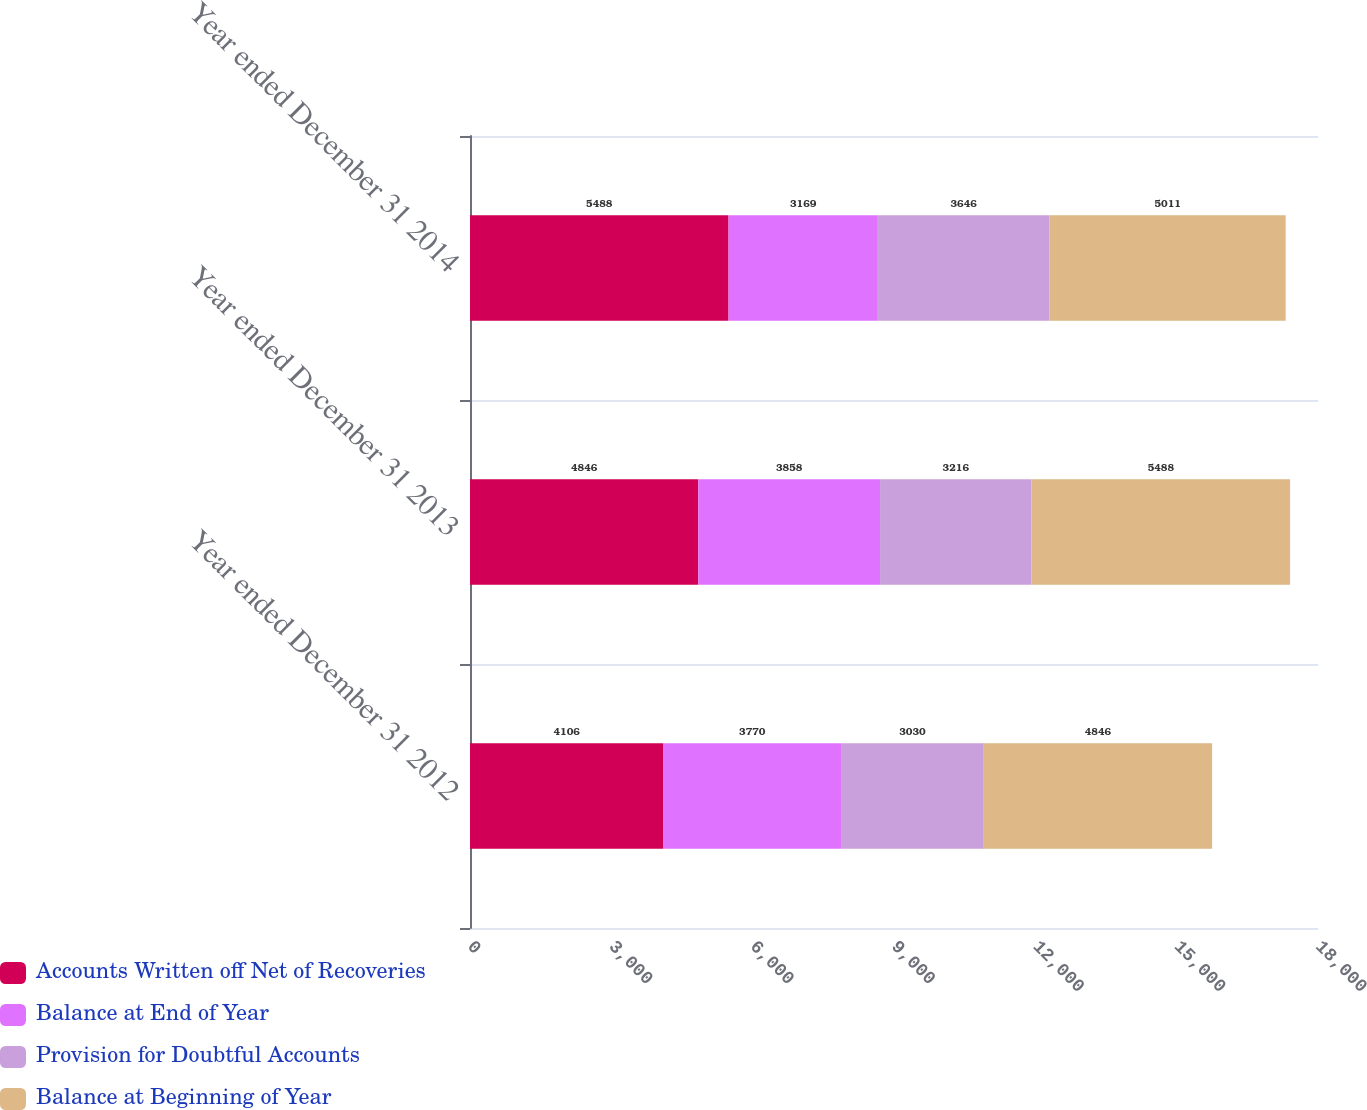Convert chart to OTSL. <chart><loc_0><loc_0><loc_500><loc_500><stacked_bar_chart><ecel><fcel>Year ended December 31 2012<fcel>Year ended December 31 2013<fcel>Year ended December 31 2014<nl><fcel>Accounts Written off Net of Recoveries<fcel>4106<fcel>4846<fcel>5488<nl><fcel>Balance at End of Year<fcel>3770<fcel>3858<fcel>3169<nl><fcel>Provision for Doubtful Accounts<fcel>3030<fcel>3216<fcel>3646<nl><fcel>Balance at Beginning of Year<fcel>4846<fcel>5488<fcel>5011<nl></chart> 